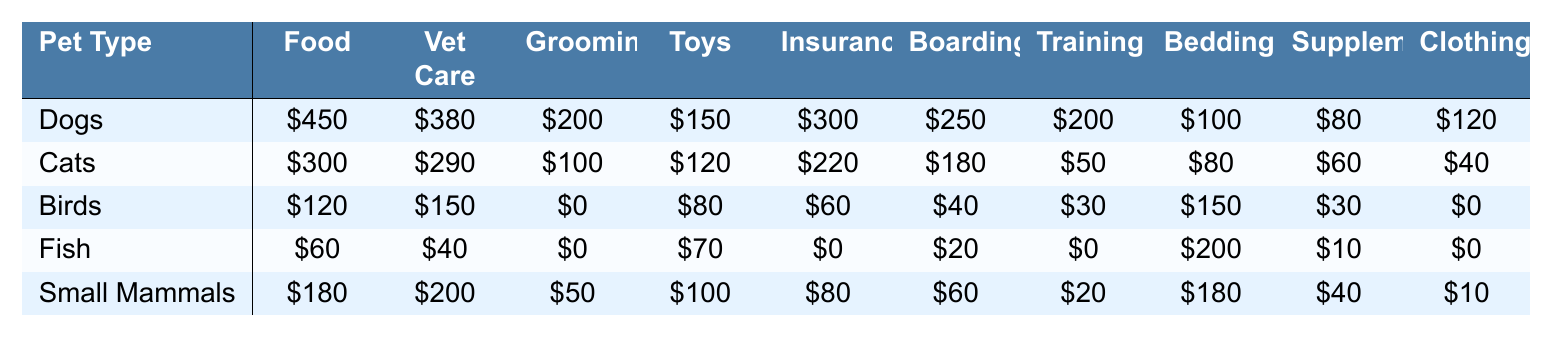What is the highest expenditure category for dogs? The highest expenditure for dogs is in the Food category, which is $450.
Answer: Food Which pet type has the lowest total expenditure? To find the total expenditure for each pet type, we sum all categories: Dogs = 450 + 380 + 200 + 150 + 300 + 250 + 200 + 100 + 80 + 120 = 2180, Cats = 300 + 290 + 100 + 120 + 220 + 180 + 50 + 80 + 60 + 40 = 1540, Birds = 120 + 150 + 0 + 80 + 60 + 40 + 30 + 150 + 30 + 0 = 660, Fish = 60 + 40 + 0 + 70 + 0 + 20 + 0 + 200 + 10 + 0 = 400, Small Mammals = 180 + 200 + 50 + 100 + 80 + 60 + 20 + 180 + 40 + 10 = 1020. The lowest total is for Fish at $400.
Answer: Fish Do small mammals have a higher expenditure on veterinary care than birds? Small Mammals spend $200 on veterinary care, while Birds spend $150. Thus, Small Mammals have a higher expenditure.
Answer: Yes What is the average expenditure on Toys and Accessories across all pet types? The sum for Toys and Accessories is 150 + 120 + 80 + 70 + 100 = 620. There are 5 pet types, so the average is 620 / 5 = 124.
Answer: 124 Which pet type has no expenditures on Grooming? In the table, Birds and Fish both have $0 expenditures in the Grooming category.
Answer: Birds and Fish What is the total expenditure for cats across all categories? Summing all expenditures for Cats gives: 300 (Food) + 290 (Veterinary Care) + 100 (Grooming) + 120 (Toys and Accessories) + 220 (Insurance) + 180 (Boarding) + 50 (Training) + 80 (Bedding) + 60 (Supplements) + 40 (Clothing) = 1540.
Answer: 1540 Is the total expenditure of Dogs higher than the total of Small Mammals? Total for Dogs is 2180, and total for Small Mammals is 1020. Since 2180 is higher than 1020, the answer is yes.
Answer: Yes What is the difference between the highest and lowest expenditure on Insurance? Dogs spend $300 on Insurance (highest), and Fish spend $0 (lowest). The difference is 300 - 0 = 300.
Answer: 300 Which category has the maximum expenditure for Cats? For Cats, the maximum expenditure is in Veterinary Care at $290, when compared to all other categories.
Answer: Veterinary Care How much do birds spend on Bedding compared to Fish? Birds spend $150 on Bedding, while Fish spend $200. Fish have a higher expenditure in this category, as 200 > 150.
Answer: Fish spend more 